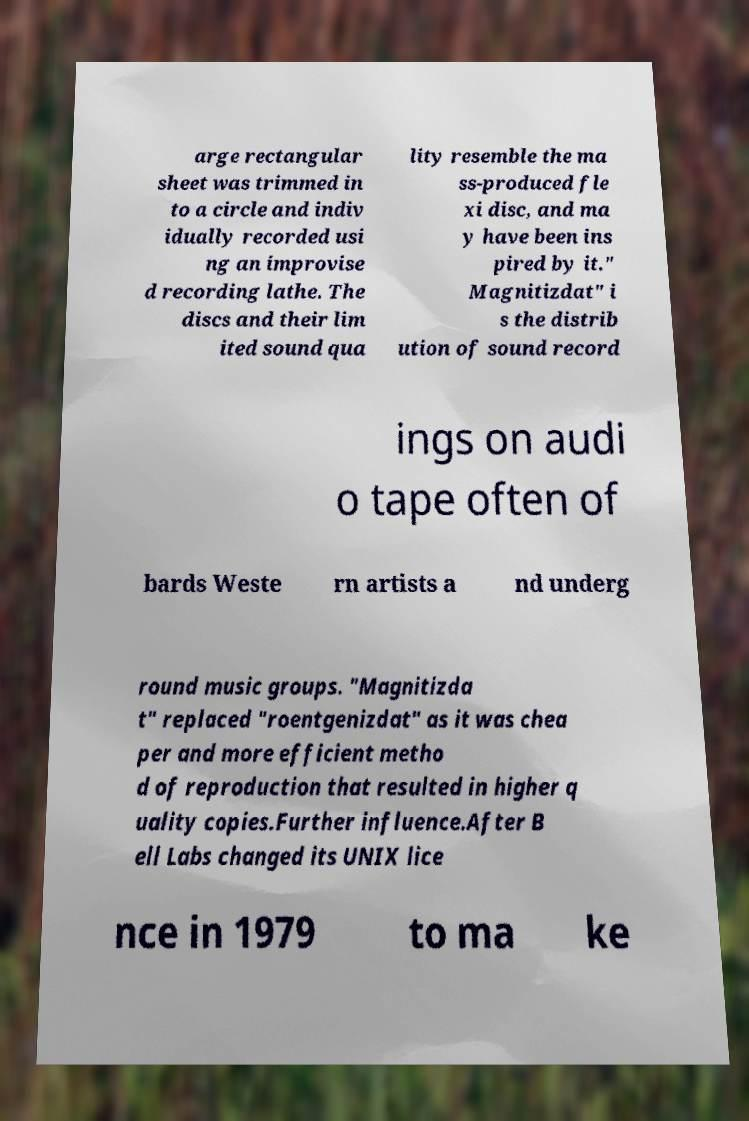I need the written content from this picture converted into text. Can you do that? arge rectangular sheet was trimmed in to a circle and indiv idually recorded usi ng an improvise d recording lathe. The discs and their lim ited sound qua lity resemble the ma ss-produced fle xi disc, and ma y have been ins pired by it." Magnitizdat" i s the distrib ution of sound record ings on audi o tape often of bards Weste rn artists a nd underg round music groups. "Magnitizda t" replaced "roentgenizdat" as it was chea per and more efficient metho d of reproduction that resulted in higher q uality copies.Further influence.After B ell Labs changed its UNIX lice nce in 1979 to ma ke 